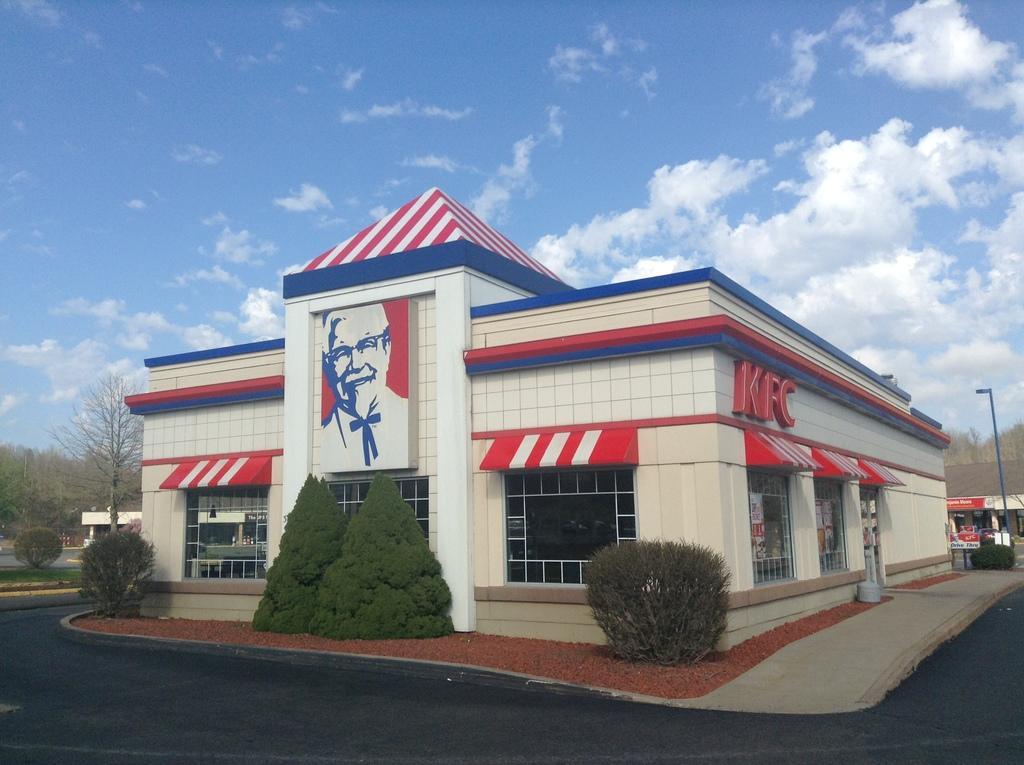How would you summarize this image in a sentence or two? There is a road and plants present at the bottom of this image. We can see trees and a building in the middle of this image. The cloudy sky is in the background. 